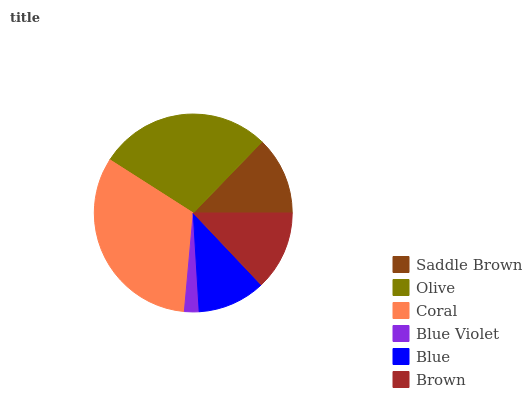Is Blue Violet the minimum?
Answer yes or no. Yes. Is Coral the maximum?
Answer yes or no. Yes. Is Olive the minimum?
Answer yes or no. No. Is Olive the maximum?
Answer yes or no. No. Is Olive greater than Saddle Brown?
Answer yes or no. Yes. Is Saddle Brown less than Olive?
Answer yes or no. Yes. Is Saddle Brown greater than Olive?
Answer yes or no. No. Is Olive less than Saddle Brown?
Answer yes or no. No. Is Brown the high median?
Answer yes or no. Yes. Is Saddle Brown the low median?
Answer yes or no. Yes. Is Blue Violet the high median?
Answer yes or no. No. Is Blue the low median?
Answer yes or no. No. 